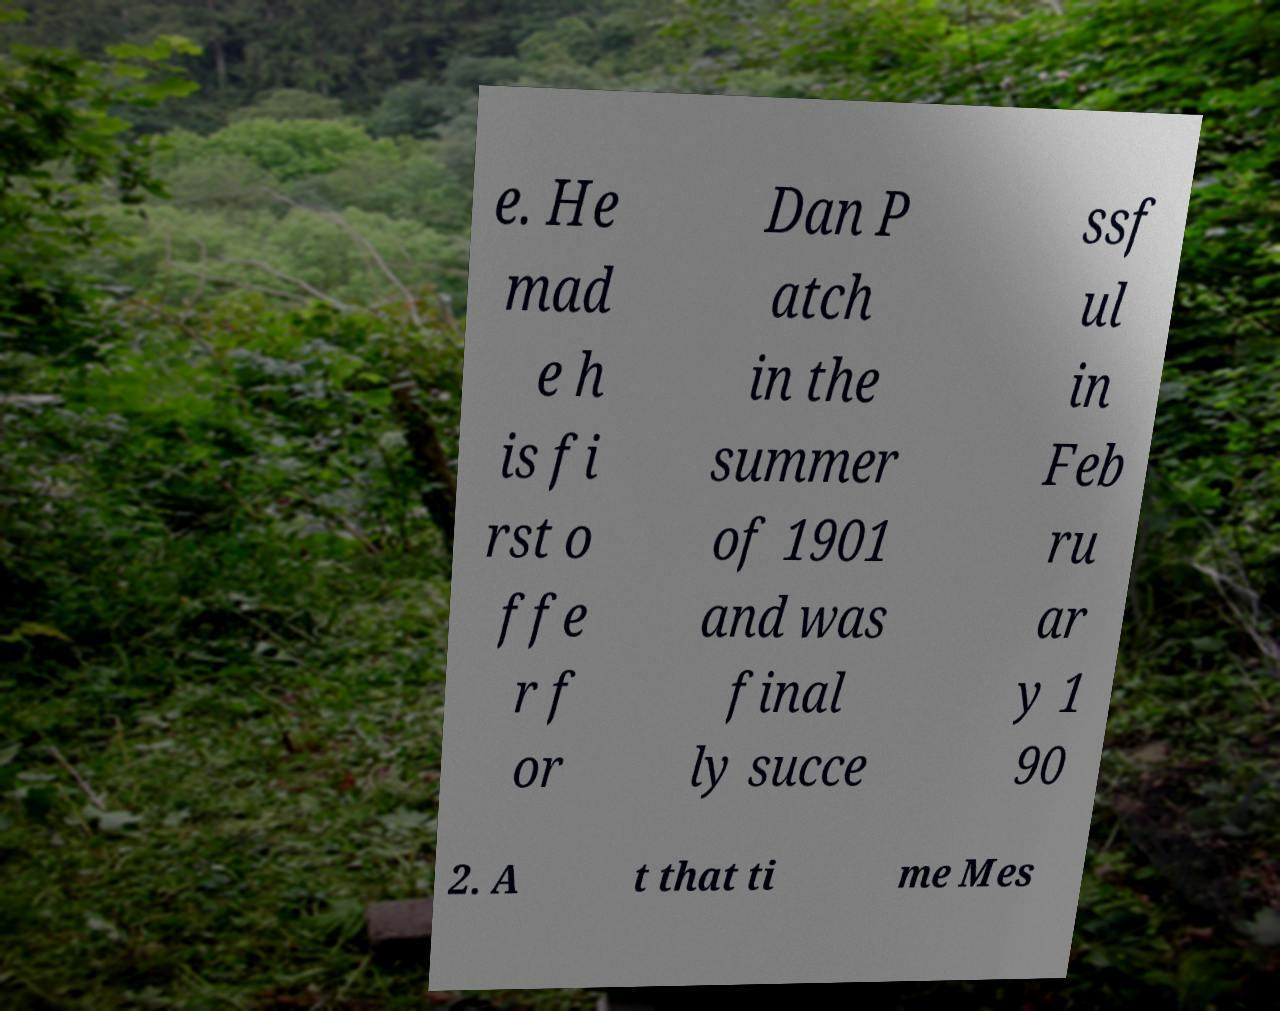Could you assist in decoding the text presented in this image and type it out clearly? e. He mad e h is fi rst o ffe r f or Dan P atch in the summer of 1901 and was final ly succe ssf ul in Feb ru ar y 1 90 2. A t that ti me Mes 